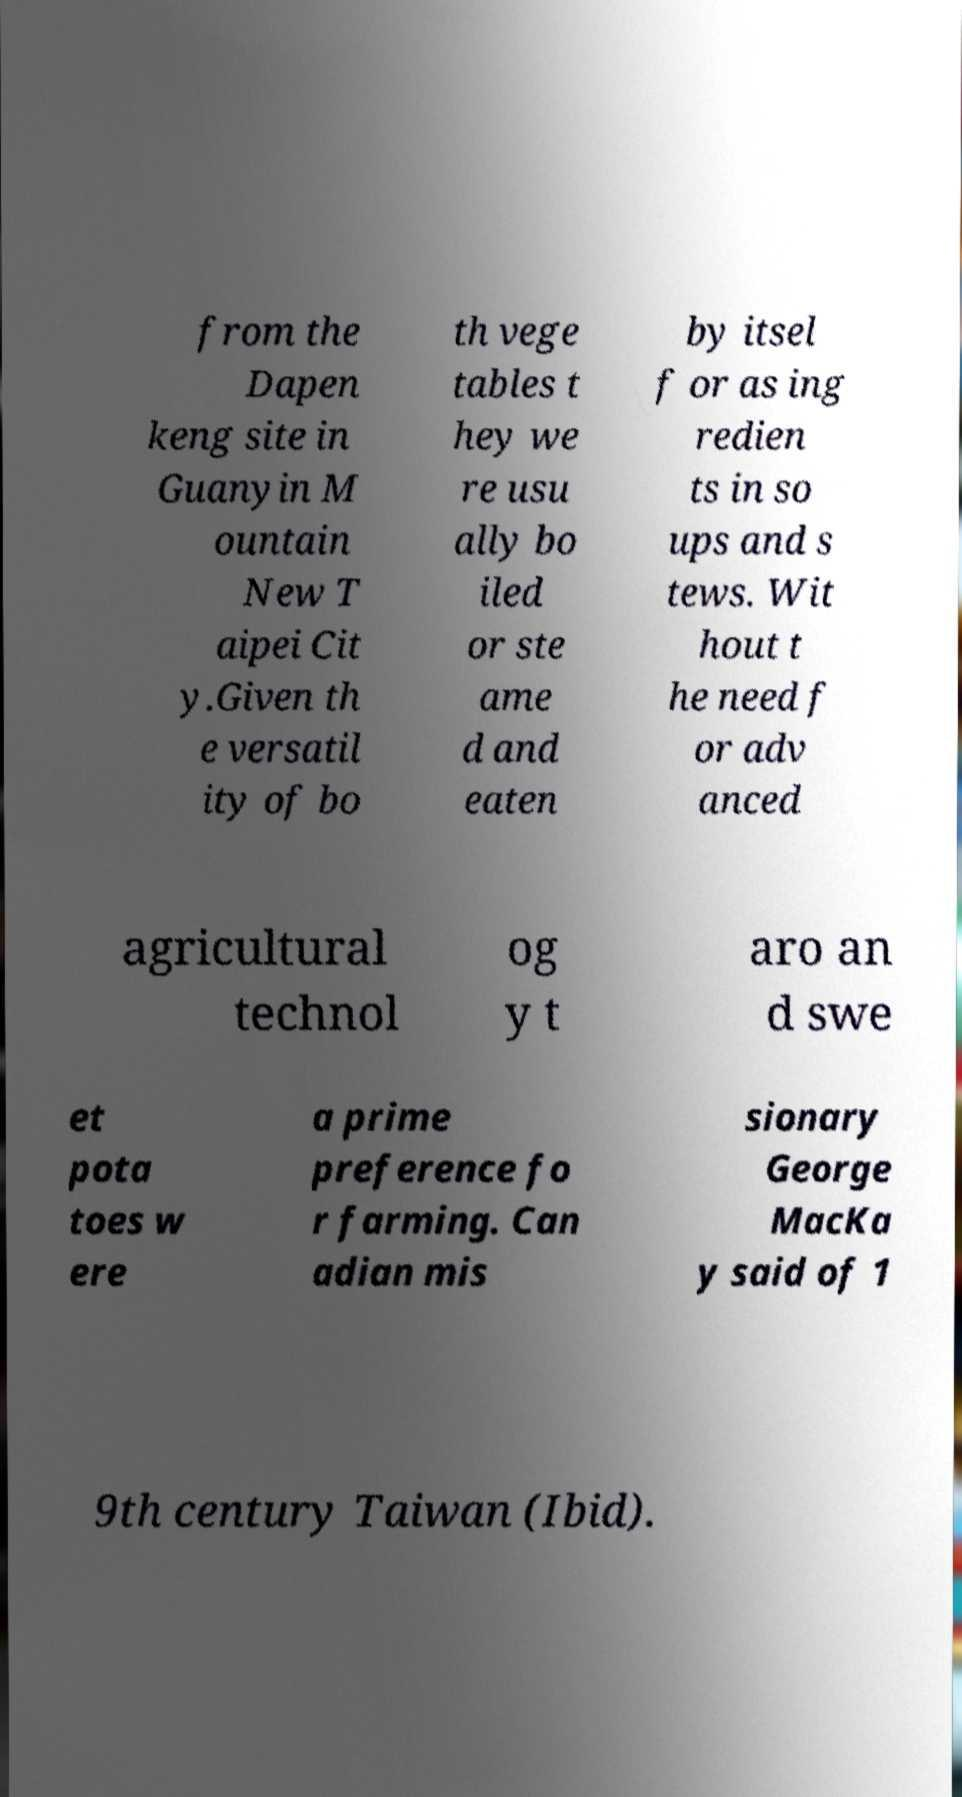For documentation purposes, I need the text within this image transcribed. Could you provide that? from the Dapen keng site in Guanyin M ountain New T aipei Cit y.Given th e versatil ity of bo th vege tables t hey we re usu ally bo iled or ste ame d and eaten by itsel f or as ing redien ts in so ups and s tews. Wit hout t he need f or adv anced agricultural technol og y t aro an d swe et pota toes w ere a prime preference fo r farming. Can adian mis sionary George MacKa y said of 1 9th century Taiwan (Ibid). 